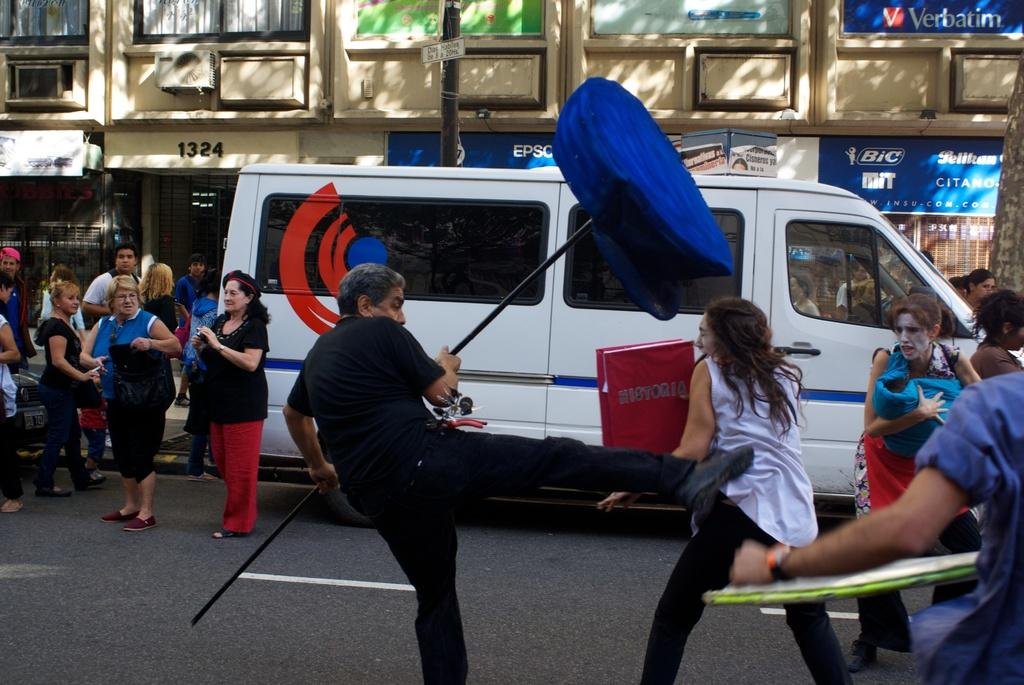<image>
Share a concise interpretation of the image provided. A street scene on which the number 1324 is visible in black letters. 